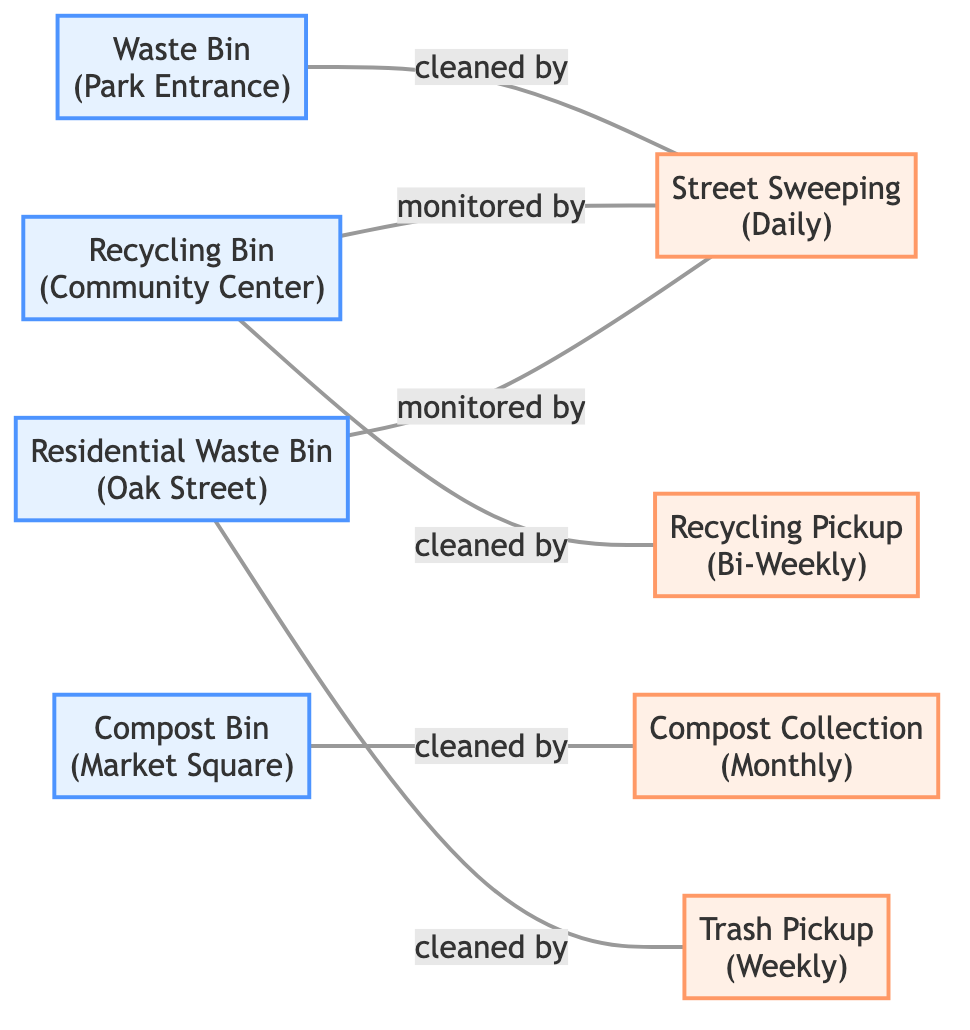What type of disposal point is located at Oak Street? The node corresponding to Oak Street is labeled as "Residential Waste Bin," which identifies it as a disposal point.
Answer: Residential Waste Bin How many disposal points are present in the diagram? By counting the nodes designated as "disposal point," we find a total of four: Waste Bin, Recycling Bin, Compost Bin, and Residential Waste Bin.
Answer: 4 What is the frequency of the Compost Collection Schedule? The node for Compost Collection Schedule specifically states that it has a frequency of "Monthly."
Answer: Monthly Which disposal point is cleaned by the Street Sweeping Schedule? The edge from the Waste Bin node indicates it is connected to the Street Sweeping Schedule with the relationship "cleaned by."
Answer: Waste Bin What is the relationship between the Recycling Bin and the Street Sweeping Schedule? There is no direct edge connecting the Recycling Bin to the Street Sweeping Schedule, which means there is no relationship specified between them.
Answer: None Which type of cleanup frequency do both the Recycling Bin and the Residential Waste Bin have a relationship with? The Recycling Bin is connected to the Recycling Pickup Schedule (Bi-Weekly) and is also monitored by the Street Sweeping Schedule. The Residential Waste Bin is connected to the Trash Pickup Schedule (Weekly) and monitored by the same Street Sweeping Schedule. Hence, the common cleanup frequency they both have a relationship with is the Street Sweeping Schedule (Daily).
Answer: Street Sweeping Schedule How many edges are in the diagram? By counting the edges listed in the data, there are a total of six edges representing the relationships between the disposal points and the cleanup frequencies.
Answer: 6 Which disposal point has the least frequent cleanup schedule? The Compost Bin, which is cleaned by the Compost Collection Schedule, has a frequency identified as "Monthly," making it the least frequent.
Answer: Compost Bin 